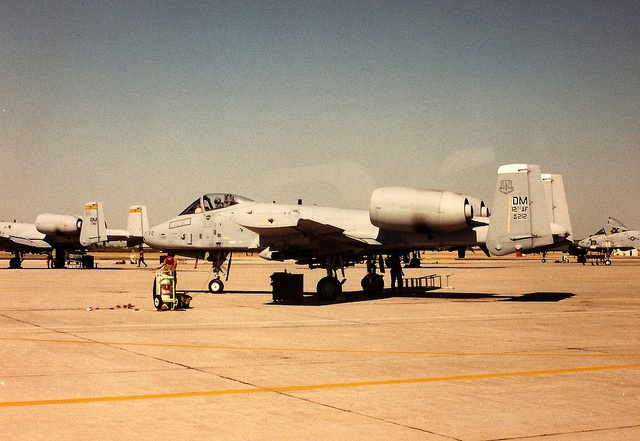Describe the objects in this image and their specific colors. I can see airplane in gray, black, tan, and beige tones, airplane in gray, black, and tan tones, airplane in gray, tan, and black tones, people in gray, black, and tan tones, and people in gray, black, brown, maroon, and tan tones in this image. 